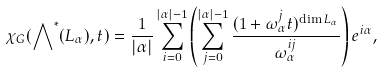Convert formula to latex. <formula><loc_0><loc_0><loc_500><loc_500>\chi _ { G } ( \bigwedge \nolimits ^ { * } ( L _ { \alpha } ) , t ) = \frac { 1 } { | \alpha | } \sum _ { i = 0 } ^ { | \alpha | - 1 } \left ( \sum _ { j = 0 } ^ { | \alpha | - 1 } \frac { ( 1 + \omega _ { \alpha } ^ { j } t ) ^ { \dim L _ { \alpha } } } { \omega _ { \alpha } ^ { i j } } \right ) e ^ { i \alpha } ,</formula> 